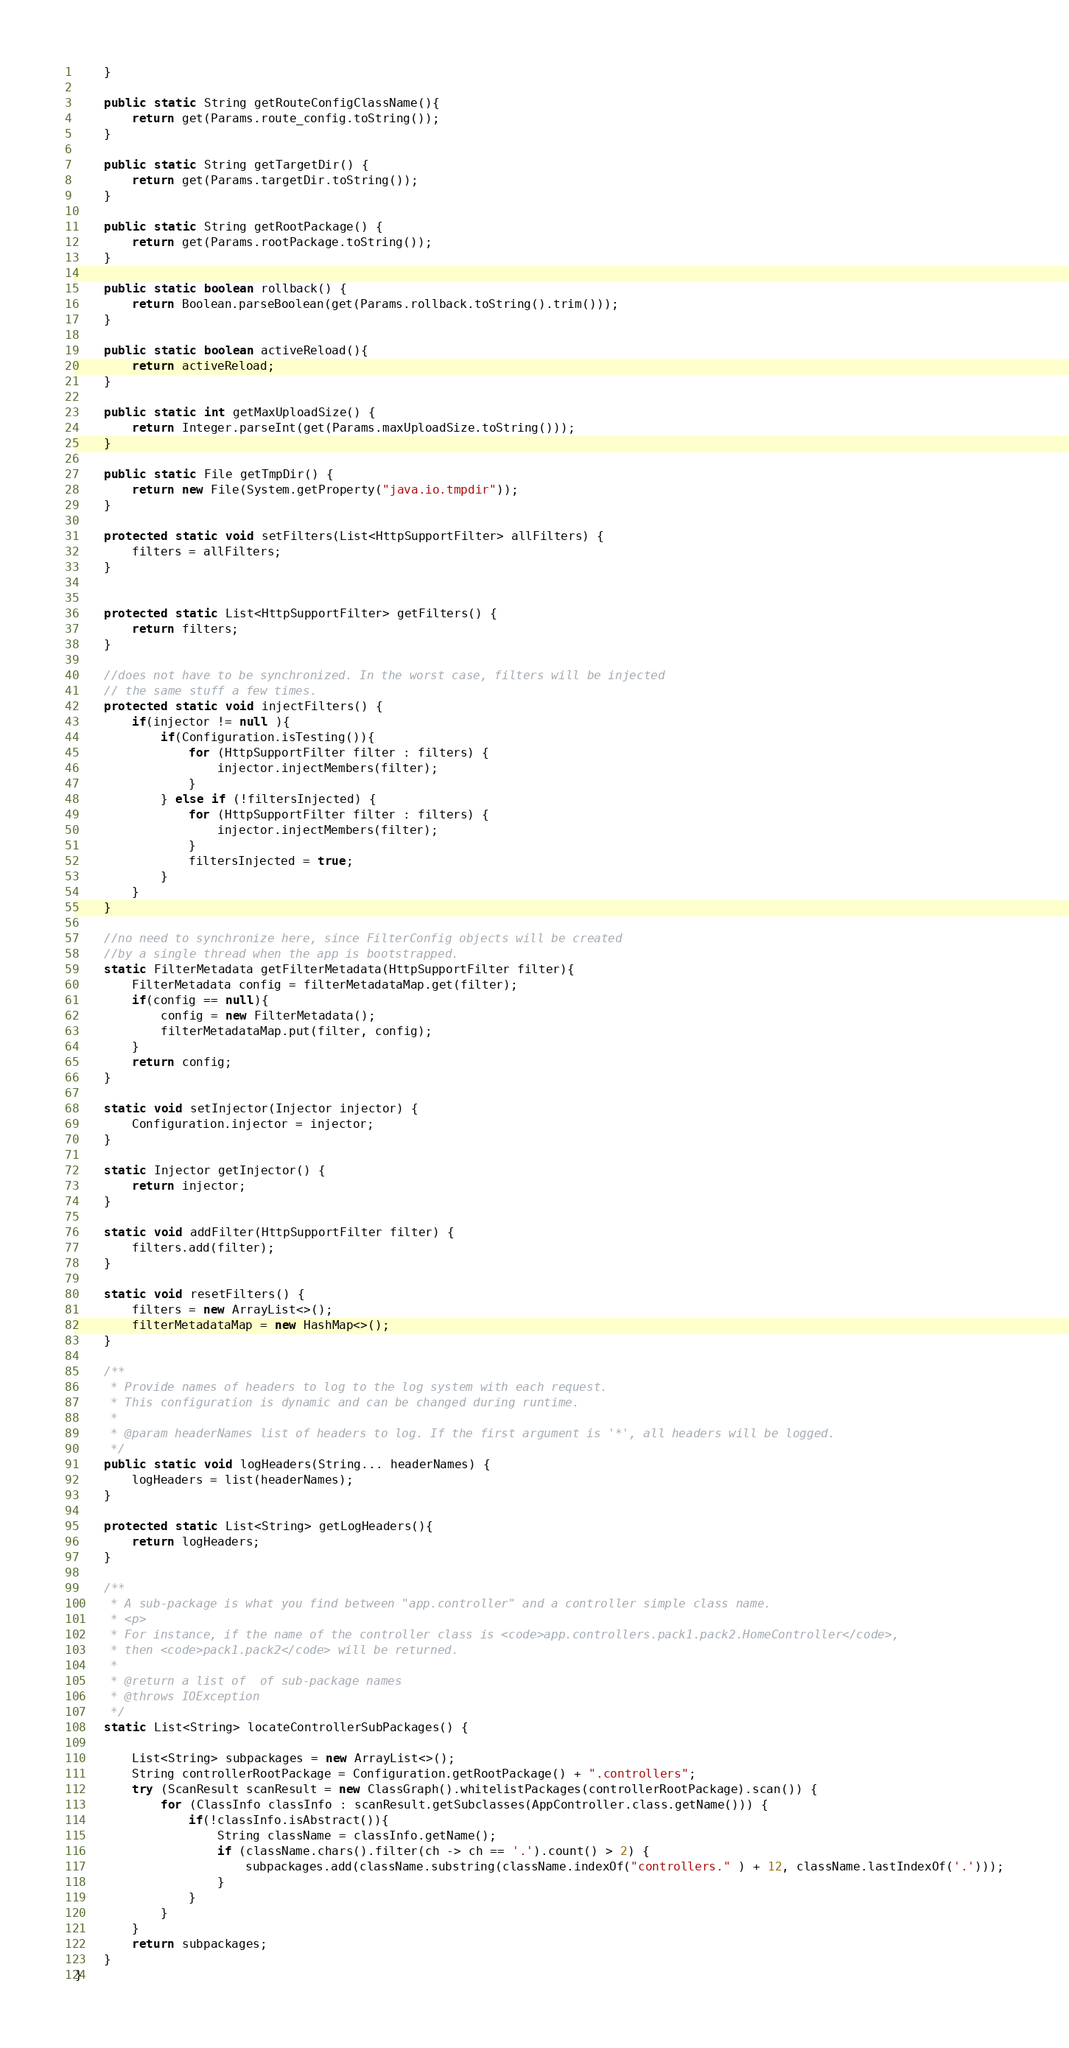<code> <loc_0><loc_0><loc_500><loc_500><_Java_>    }

    public static String getRouteConfigClassName(){
        return get(Params.route_config.toString());
    }

    public static String getTargetDir() {
        return get(Params.targetDir.toString());  
    }

    public static String getRootPackage() {
        return get(Params.rootPackage.toString());  
    }

    public static boolean rollback() {
        return Boolean.parseBoolean(get(Params.rollback.toString().trim()));  
    }

    public static boolean activeReload(){
        return activeReload;
    }

    public static int getMaxUploadSize() {
        return Integer.parseInt(get(Params.maxUploadSize.toString()));
    }

    public static File getTmpDir() {
        return new File(System.getProperty("java.io.tmpdir"));
    }

    protected static void setFilters(List<HttpSupportFilter> allFilters) {
        filters = allFilters;
    }


    protected static List<HttpSupportFilter> getFilters() {
        return filters;
    }

    //does not have to be synchronized. In the worst case, filters will be injected
    // the same stuff a few times.
    protected static void injectFilters() {
        if(injector != null ){
            if(Configuration.isTesting()){
                for (HttpSupportFilter filter : filters) {
                    injector.injectMembers(filter);
                }
            } else if (!filtersInjected) {
                for (HttpSupportFilter filter : filters) {
                    injector.injectMembers(filter);
                }
                filtersInjected = true;
            }
        }
    }

    //no need to synchronize here, since FilterConfig objects will be created
    //by a single thread when the app is bootstrapped.
    static FilterMetadata getFilterMetadata(HttpSupportFilter filter){
        FilterMetadata config = filterMetadataMap.get(filter);
        if(config == null){
            config = new FilterMetadata();
            filterMetadataMap.put(filter, config);
        }
        return config;
    }

    static void setInjector(Injector injector) {
        Configuration.injector = injector;
    }

    static Injector getInjector() {
        return injector;
    }

    static void addFilter(HttpSupportFilter filter) {
        filters.add(filter);
    }

    static void resetFilters() {
        filters = new ArrayList<>();
        filterMetadataMap = new HashMap<>();
    }

    /**
     * Provide names of headers to log to the log system with each request.
     * This configuration is dynamic and can be changed during runtime.
     *
     * @param headerNames list of headers to log. If the first argument is '*', all headers will be logged.
     */
    public static void logHeaders(String... headerNames) {
        logHeaders = list(headerNames);
    }

    protected static List<String> getLogHeaders(){
        return logHeaders;
    }

    /**
     * A sub-package is what you find between "app.controller" and a controller simple class name.
     * <p>
     * For instance, if the name of the controller class is <code>app.controllers.pack1.pack2.HomeController</code>,
     * then <code>pack1.pack2</code> will be returned.
     *
     * @return a list of  of sub-package names
     * @throws IOException
     */
    static List<String> locateControllerSubPackages() {

        List<String> subpackages = new ArrayList<>();
        String controllerRootPackage = Configuration.getRootPackage() + ".controllers";
        try (ScanResult scanResult = new ClassGraph().whitelistPackages(controllerRootPackage).scan()) {
            for (ClassInfo classInfo : scanResult.getSubclasses(AppController.class.getName())) {
                if(!classInfo.isAbstract()){
                    String className = classInfo.getName();
                    if (className.chars().filter(ch -> ch == '.').count() > 2) {
                        subpackages.add(className.substring(className.indexOf("controllers." ) + 12, className.lastIndexOf('.')));
                    }
                }
            }
        }
        return subpackages;
    }
}
</code> 